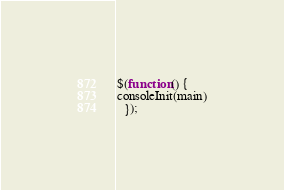<code> <loc_0><loc_0><loc_500><loc_500><_JavaScript_>
$(function() {
consoleInit(main)
  });
</code> 